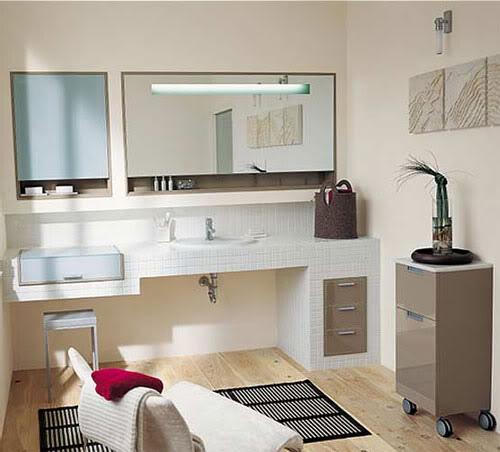Is it nighttime?
Be succinct. No. How many mirrors are there?
Quick response, please. 2. Where is the chair?
Keep it brief. Bathroom. Do the cabinets match the counter?
Keep it brief. Yes. 